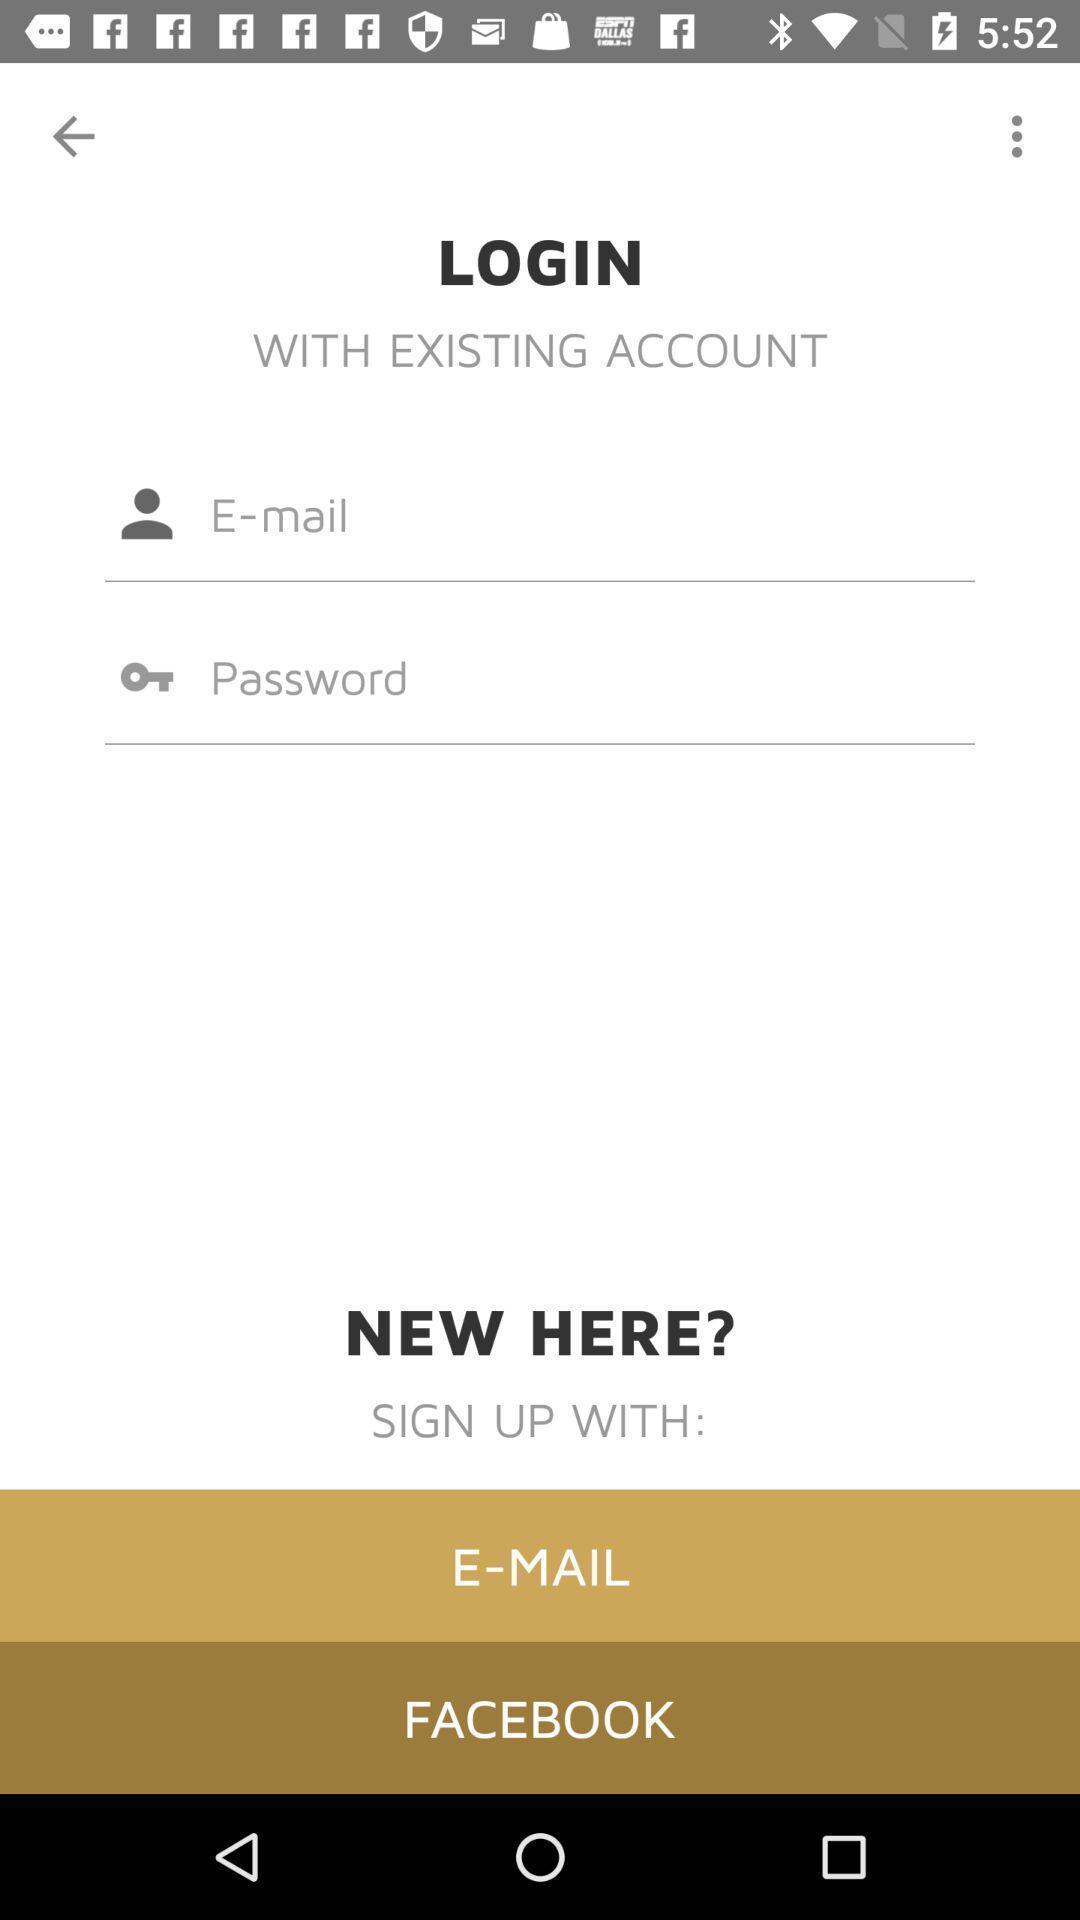Provide a textual representation of this image. Login page of a dating app. 